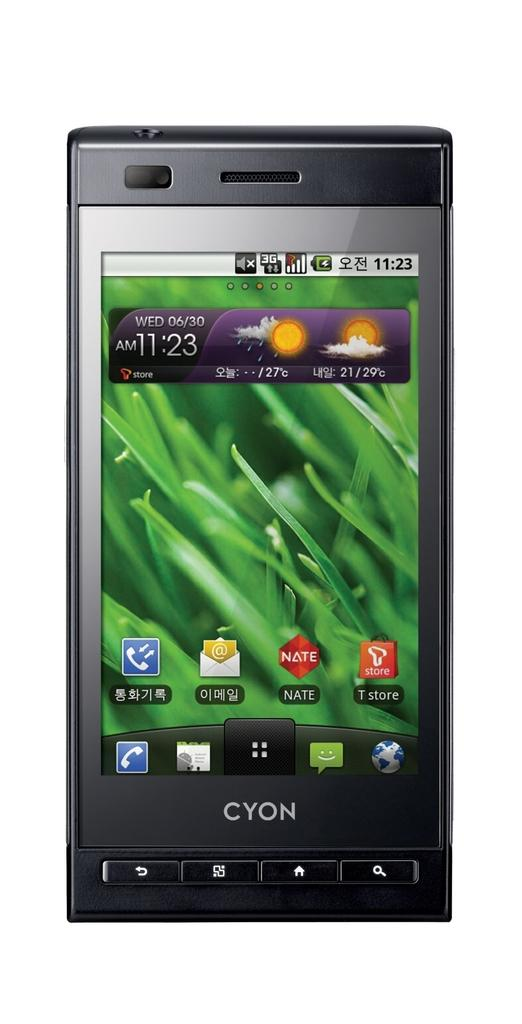<image>
Create a compact narrative representing the image presented. The time on the cellphone is currently 11:23 AM on Wed 06/30. 